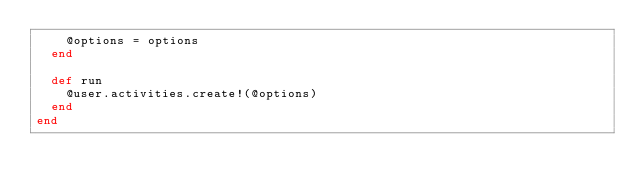<code> <loc_0><loc_0><loc_500><loc_500><_Ruby_>    @options = options
  end

  def run
    @user.activities.create!(@options)
  end
end
</code> 